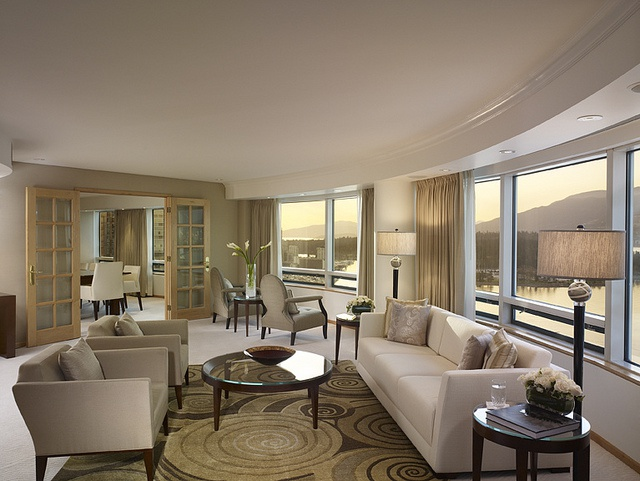Describe the objects in this image and their specific colors. I can see couch in gray and darkgray tones, couch in gray tones, chair in gray tones, chair in gray tones, and chair in gray tones in this image. 